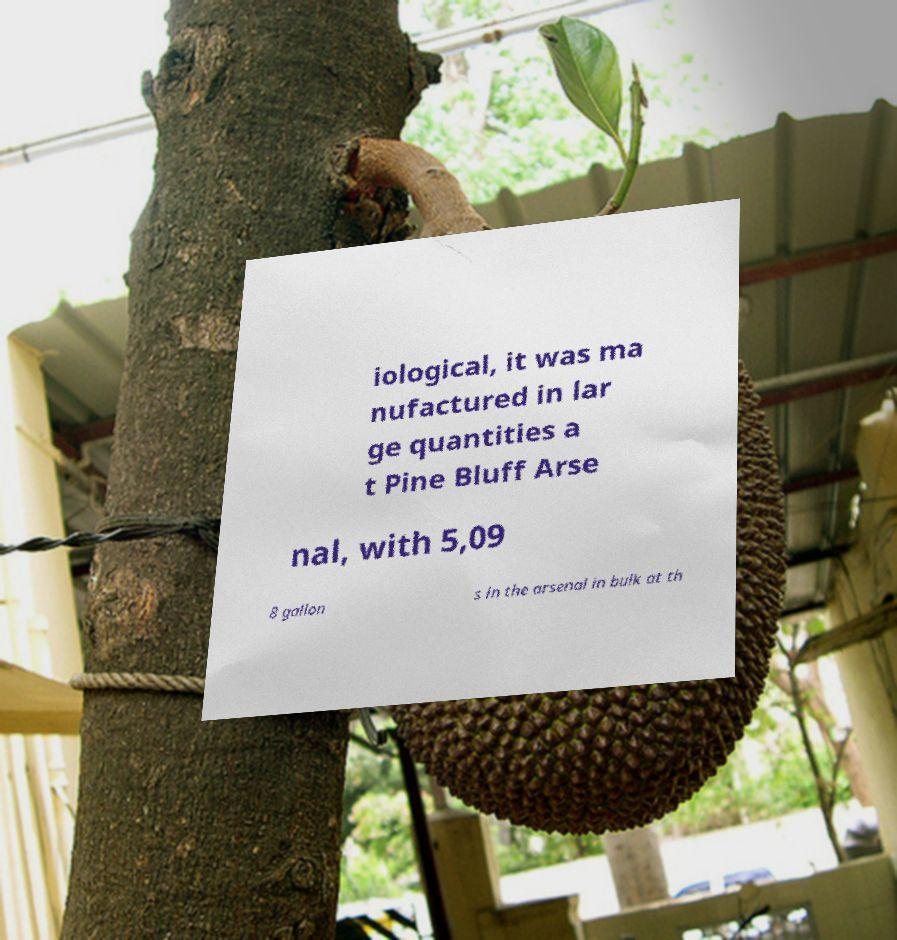Can you read and provide the text displayed in the image?This photo seems to have some interesting text. Can you extract and type it out for me? iological, it was ma nufactured in lar ge quantities a t Pine Bluff Arse nal, with 5,09 8 gallon s in the arsenal in bulk at th 